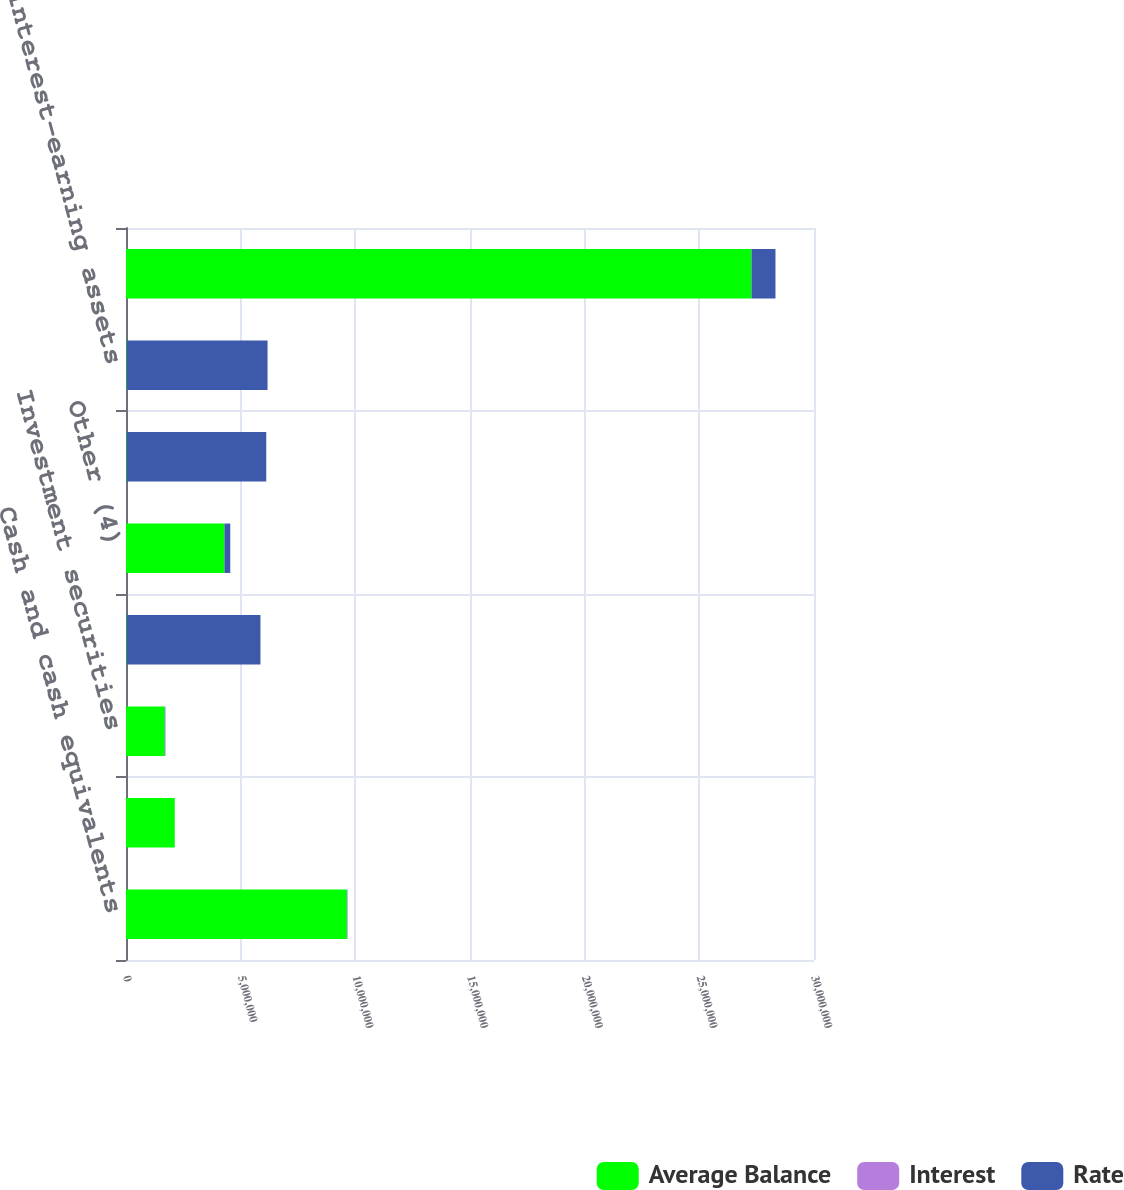Convert chart to OTSL. <chart><loc_0><loc_0><loc_500><loc_500><stacked_bar_chart><ecel><fcel>Cash and cash equivalents<fcel>Restricted cash<fcel>Investment securities<fcel>Credit card (3)<fcel>Other (4)<fcel>Total loan receivables<fcel>Total interest-earning assets<fcel>Time deposits (5)<nl><fcel>Average Balance<fcel>9.62876e+06<fcel>2.12434e+06<fcel>1.68845e+06<fcel>26222<fcel>4.2924e+06<fcel>26222<fcel>26222<fcel>2.72744e+07<nl><fcel>Interest<fcel>0.25<fcel>0.16<fcel>1.55<fcel>12.79<fcel>5.91<fcel>12.2<fcel>9.67<fcel>3.84<nl><fcel>Rate<fcel>24319<fcel>3419<fcel>26222<fcel>5.836e+06<fcel>253821<fcel>6.08982e+06<fcel>6.14622e+06<fcel>1.04611e+06<nl></chart> 